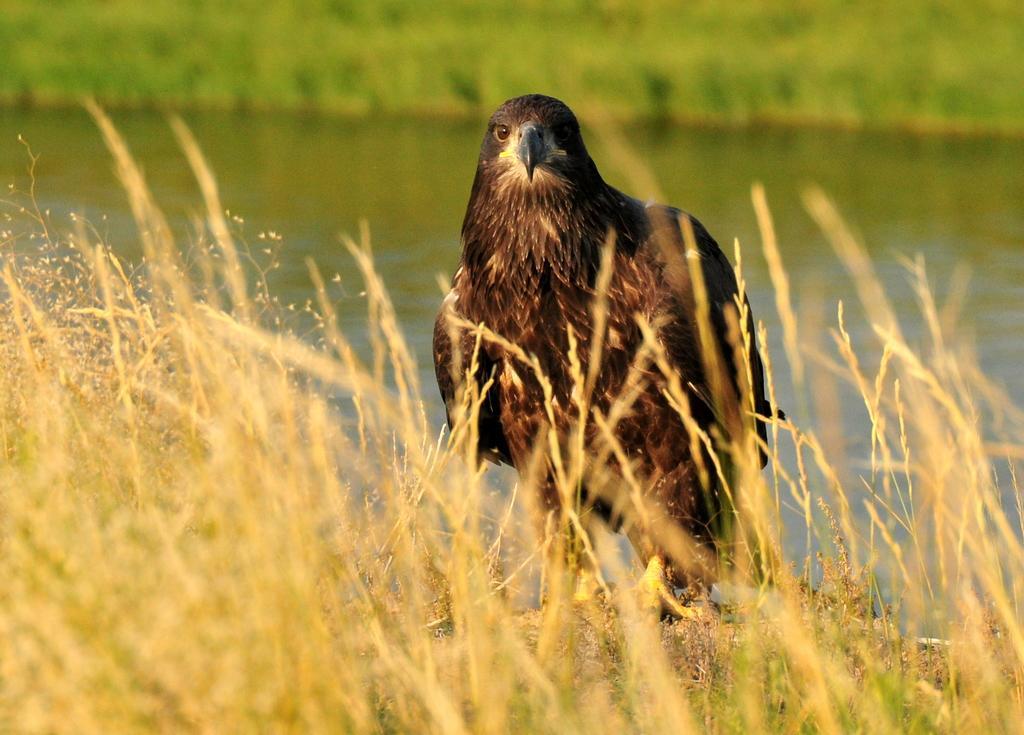In one or two sentences, can you explain what this image depicts? This is bird, there is grass and water. 